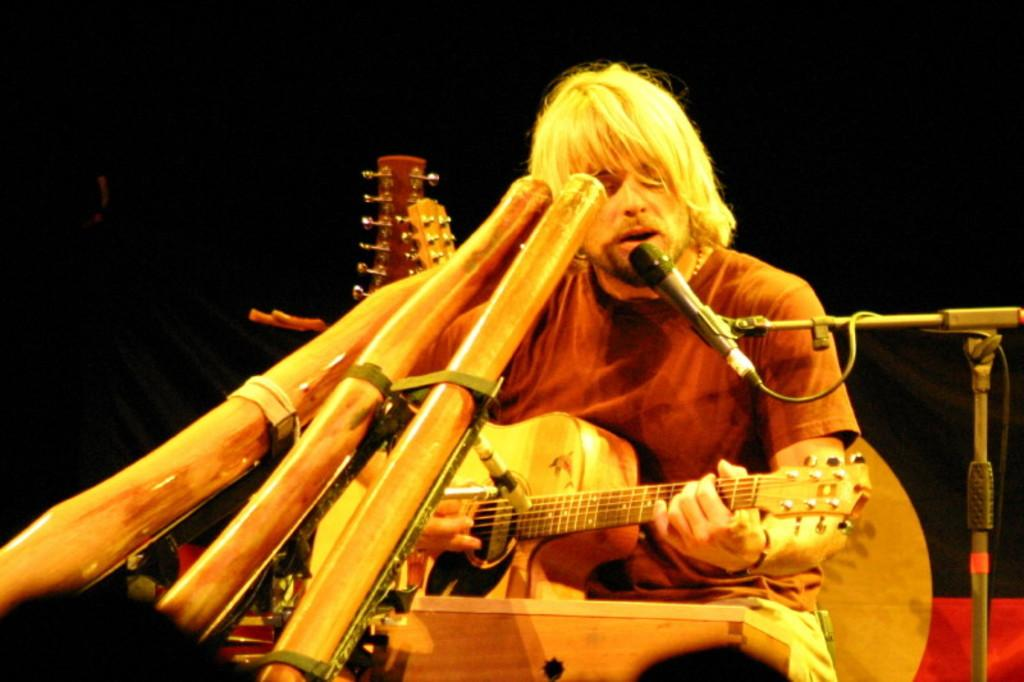What is the man in the image doing? The man is playing a guitar and singing. How is the man's voice being amplified in the image? The man is using a microphone. What other musical instruments can be seen in the image? There are other musical instruments in the image. What type of wax is being used to create the nation's flag in the image? There is no mention of a flag or wax in the image; it features a man playing a guitar, singing, and using a microphone. 